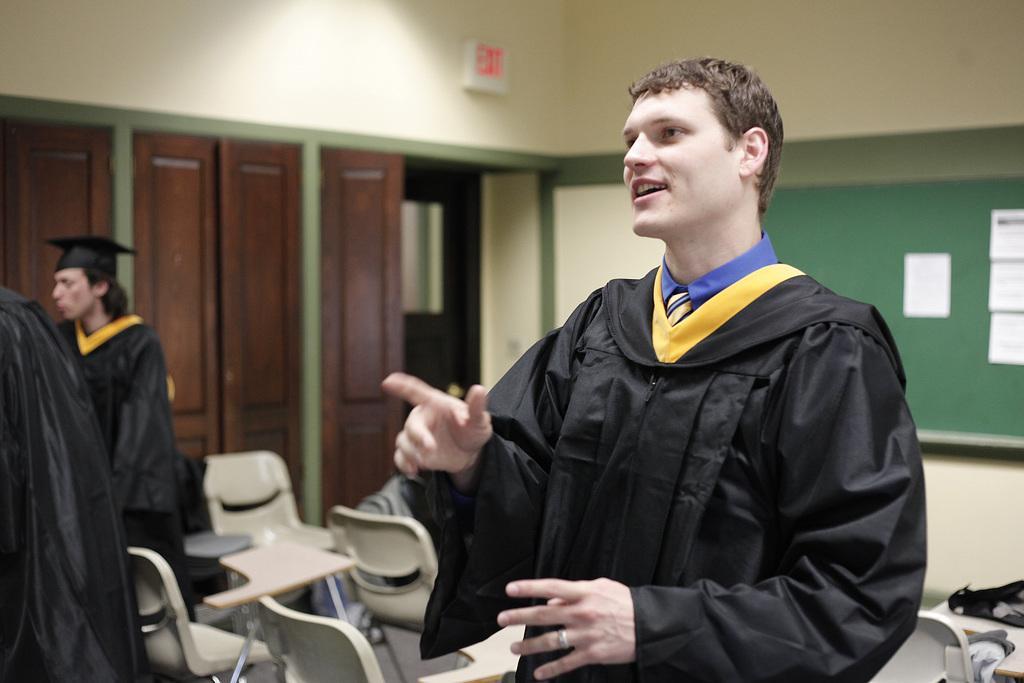Describe this image in one or two sentences. In this image, In the middle there is a man boy who is wearing a black color coat he is standing and he is smiling, In the left side there are some people standing and in the right side there is a green color board, In the background there are some brown color doors. 